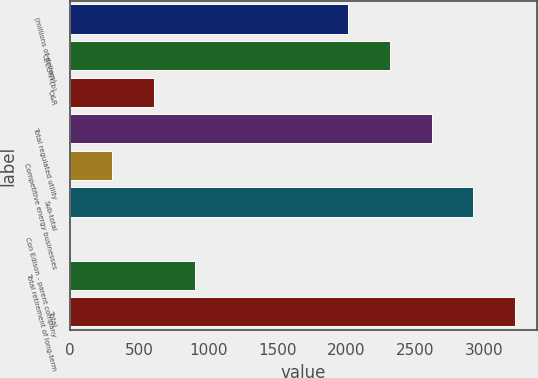Convert chart to OTSL. <chart><loc_0><loc_0><loc_500><loc_500><bar_chart><fcel>(millions of dollars)<fcel>CECONY(b)<fcel>O&R<fcel>Total regulated utility<fcel>Competitive energy businesses<fcel>Sub-total<fcel>Con Edison - parent company<fcel>Total retirement of long-term<fcel>Total<nl><fcel>2015<fcel>2316.5<fcel>605<fcel>2618<fcel>303.5<fcel>2919.5<fcel>2<fcel>906.5<fcel>3221<nl></chart> 